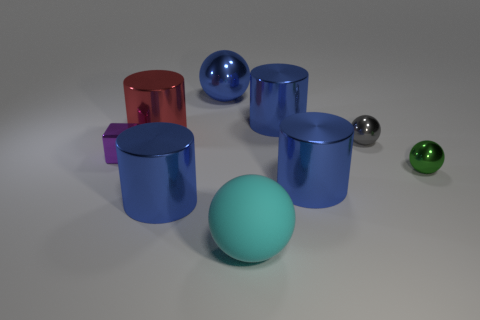Subtract all brown blocks. How many blue cylinders are left? 3 Add 1 shiny spheres. How many objects exist? 10 Subtract all gray cylinders. Subtract all green blocks. How many cylinders are left? 4 Subtract all cylinders. How many objects are left? 5 Subtract all red cylinders. Subtract all big blue shiny objects. How many objects are left? 4 Add 5 tiny purple shiny things. How many tiny purple shiny things are left? 6 Add 7 green metal objects. How many green metal objects exist? 8 Subtract 0 brown blocks. How many objects are left? 9 